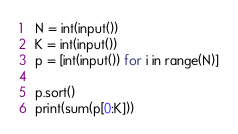<code> <loc_0><loc_0><loc_500><loc_500><_Python_>N = int(input())
K = int(input())
p = [int(input()) for i in range(N)]

p.sort()
print(sum(p[0:K]))
</code> 